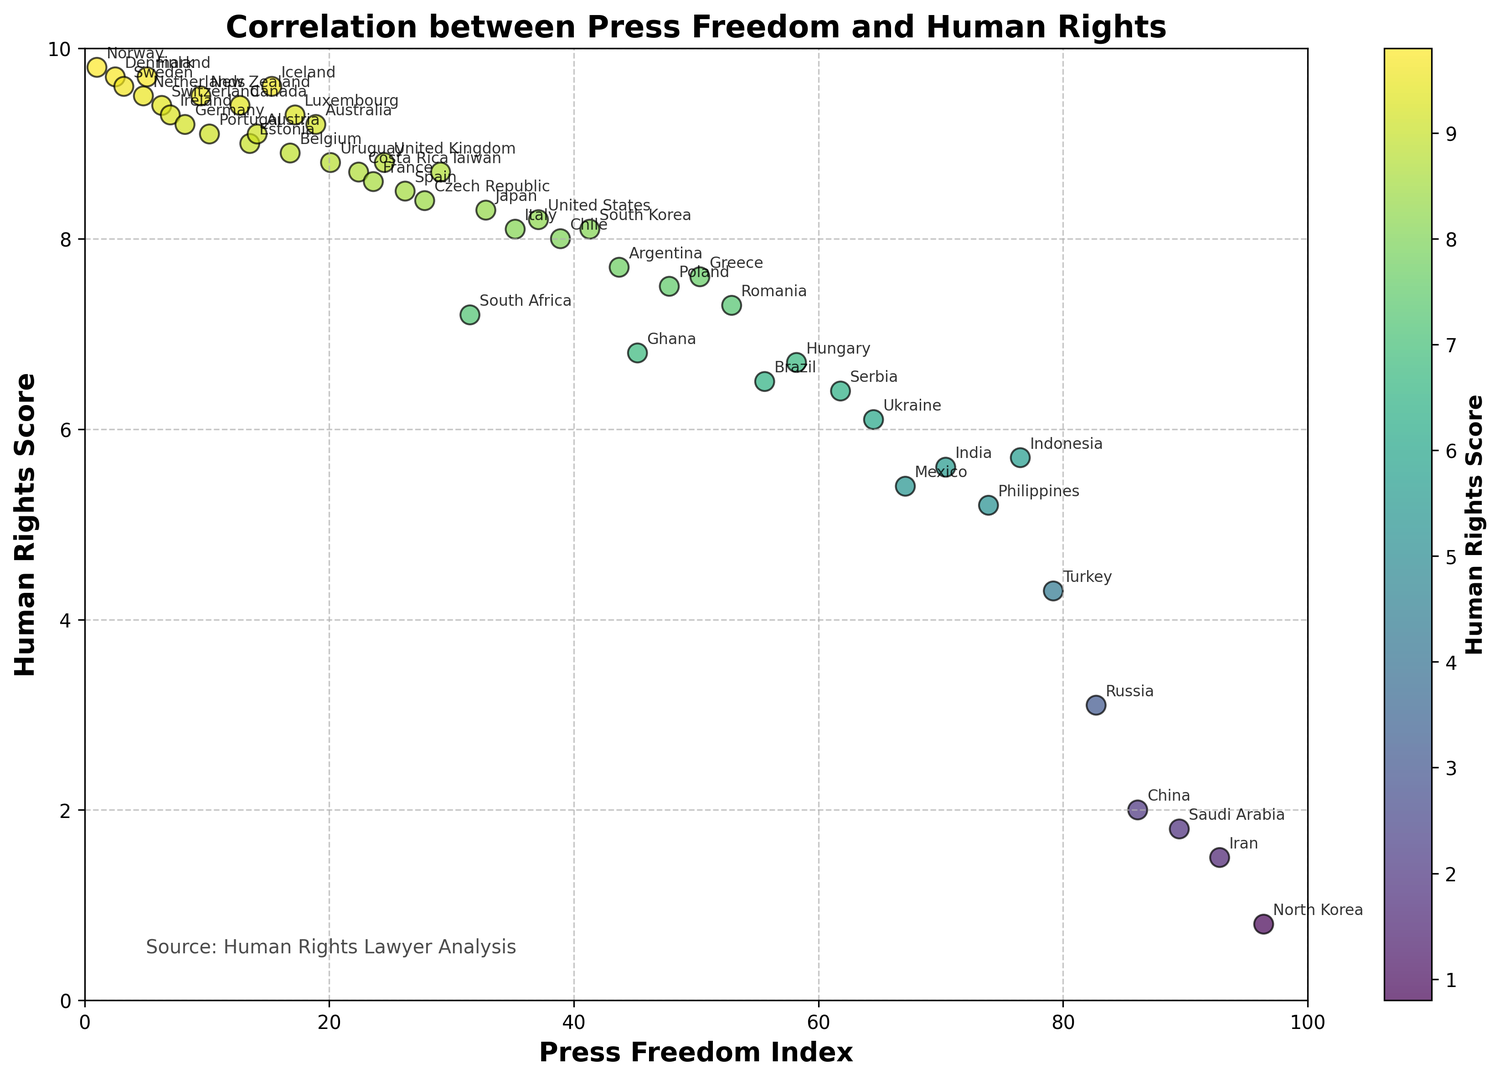What is the country with the highest Human Rights Score? The country with the highest Human Rights Score is positioned towards the top of the plot. By looking at the topmost data point, it is Norway.
Answer: Norway Which country has a better press freedom index, Finland or the United States? By checking the positions of Finland and the United States on the x-axis, Finland is much closer to the left. This signifies that Finland has a better (lower) Press Freedom Index compared to the United States.
Answer: Finland What is the range of Human Rights Scores for countries with a Press Freedom Index between 20 and 30? Identify the countries that fall between the Press Freedom Index of 20 to 30 on the x-axis. Their Human Rights Scores range from approximately 8.4 to 8.8, including countries such as Uruguay, Costa Rica, France, and the United Kingdom.
Answer: 8.4 to 8.8 How does the color of the dots change as the Human Rights Score decreases? Observe the color gradient for Human Rights Scores using the color bar. As the Human Rights Score decreases, the color of the dots shifts from yellowish-green to darker greens and finally to blue.
Answer: From yellowish-green to blue Which country, Costa Rica or South Africa, has a higher Human Rights Score? By comparing the positions of Costa Rica and South Africa on the y-axis, Costa Rica is higher up, indicating that it has a higher Human Rights Score.
Answer: Costa Rica Which geographic region shows generally higher scores in both press freedom and human rights? Examining the clusters of countries with both low Press Freedom Indices and high Human Rights Scores, it is noticeable that European countries, especially Nordic countries like Norway and Denmark, dominate this region.
Answer: Europe (Nordic countries) Are there any countries with a Press Freedom Index above 80 and Human Rights Score above 5? Check the area near Press Freedom Index values above 80 on the x-axis. All these countries (Saudi Arabia, Russia, China, North Korea) have Human Rights Scores below 5.
Answer: No What is the median Human Rights Score for the countries plotted? The total number of countries plotted is 46. To find the median Human Rights Score, order all scores and find the middle value. The median point is the average of the 23rd and 24th values, which are 8.5 (Spain) and 8.5 (Spain). Therefore, the median Human Rights Score is 8.5.
Answer: 8.5 